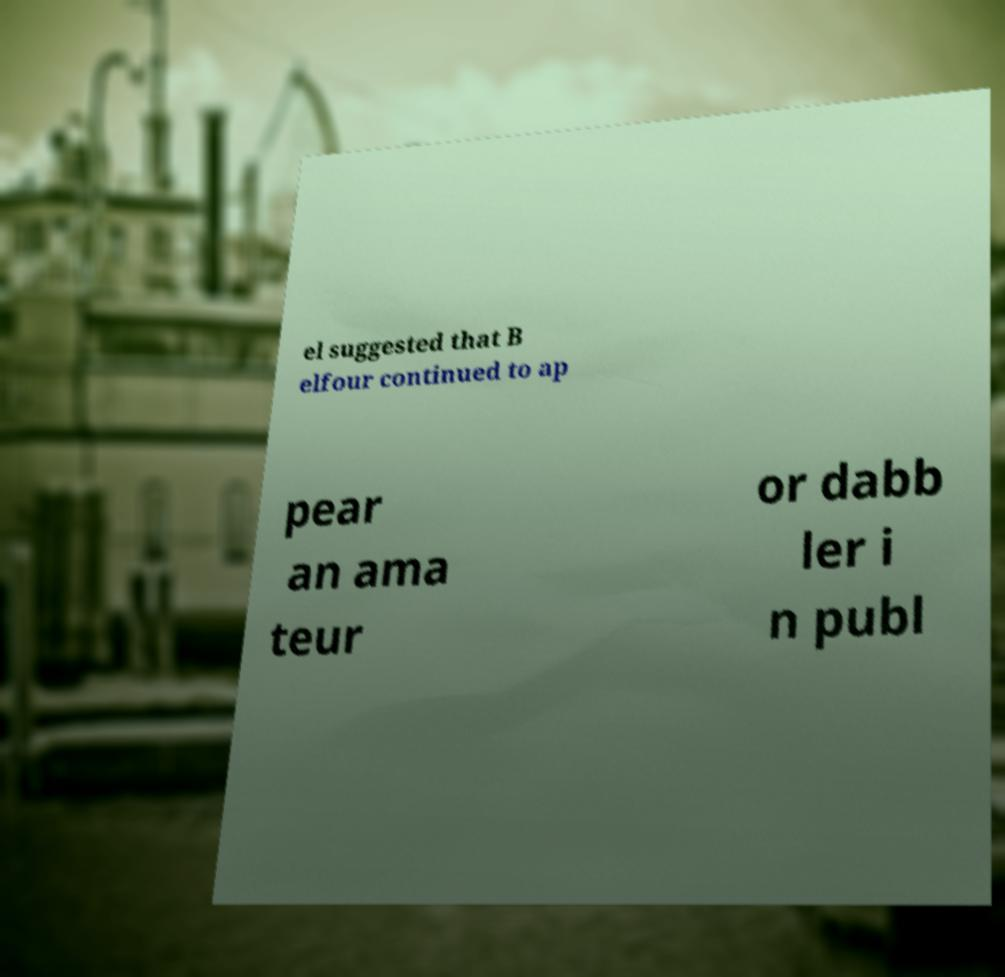Could you assist in decoding the text presented in this image and type it out clearly? el suggested that B elfour continued to ap pear an ama teur or dabb ler i n publ 